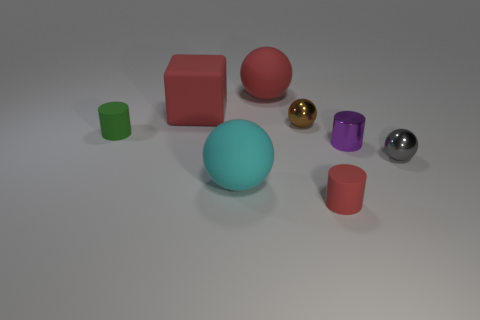There is a object that is in front of the large thing that is in front of the shiny thing that is to the left of the tiny red matte thing; what is its size?
Give a very brief answer. Small. What shape is the small brown metal object?
Offer a terse response. Sphere. What is the size of the sphere that is the same color as the big block?
Give a very brief answer. Large. How many green cylinders are left of the tiny ball to the right of the brown shiny object?
Your answer should be very brief. 1. What number of other things are there of the same material as the red block
Your answer should be compact. 4. Are the ball that is to the right of the tiny red object and the small ball that is behind the tiny purple shiny thing made of the same material?
Make the answer very short. Yes. Is the tiny gray ball made of the same material as the large block that is behind the small gray metal object?
Your response must be concise. No. There is a sphere that is to the right of the shiny sphere left of the tiny ball in front of the green thing; what color is it?
Offer a very short reply. Gray. What shape is the red matte thing that is the same size as the purple cylinder?
Your answer should be compact. Cylinder. There is a red thing in front of the purple metallic thing; is it the same size as the sphere left of the red sphere?
Provide a short and direct response. No. 